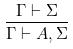<formula> <loc_0><loc_0><loc_500><loc_500>\frac { \Gamma \vdash \Sigma } { \Gamma \vdash A , \Sigma }</formula> 